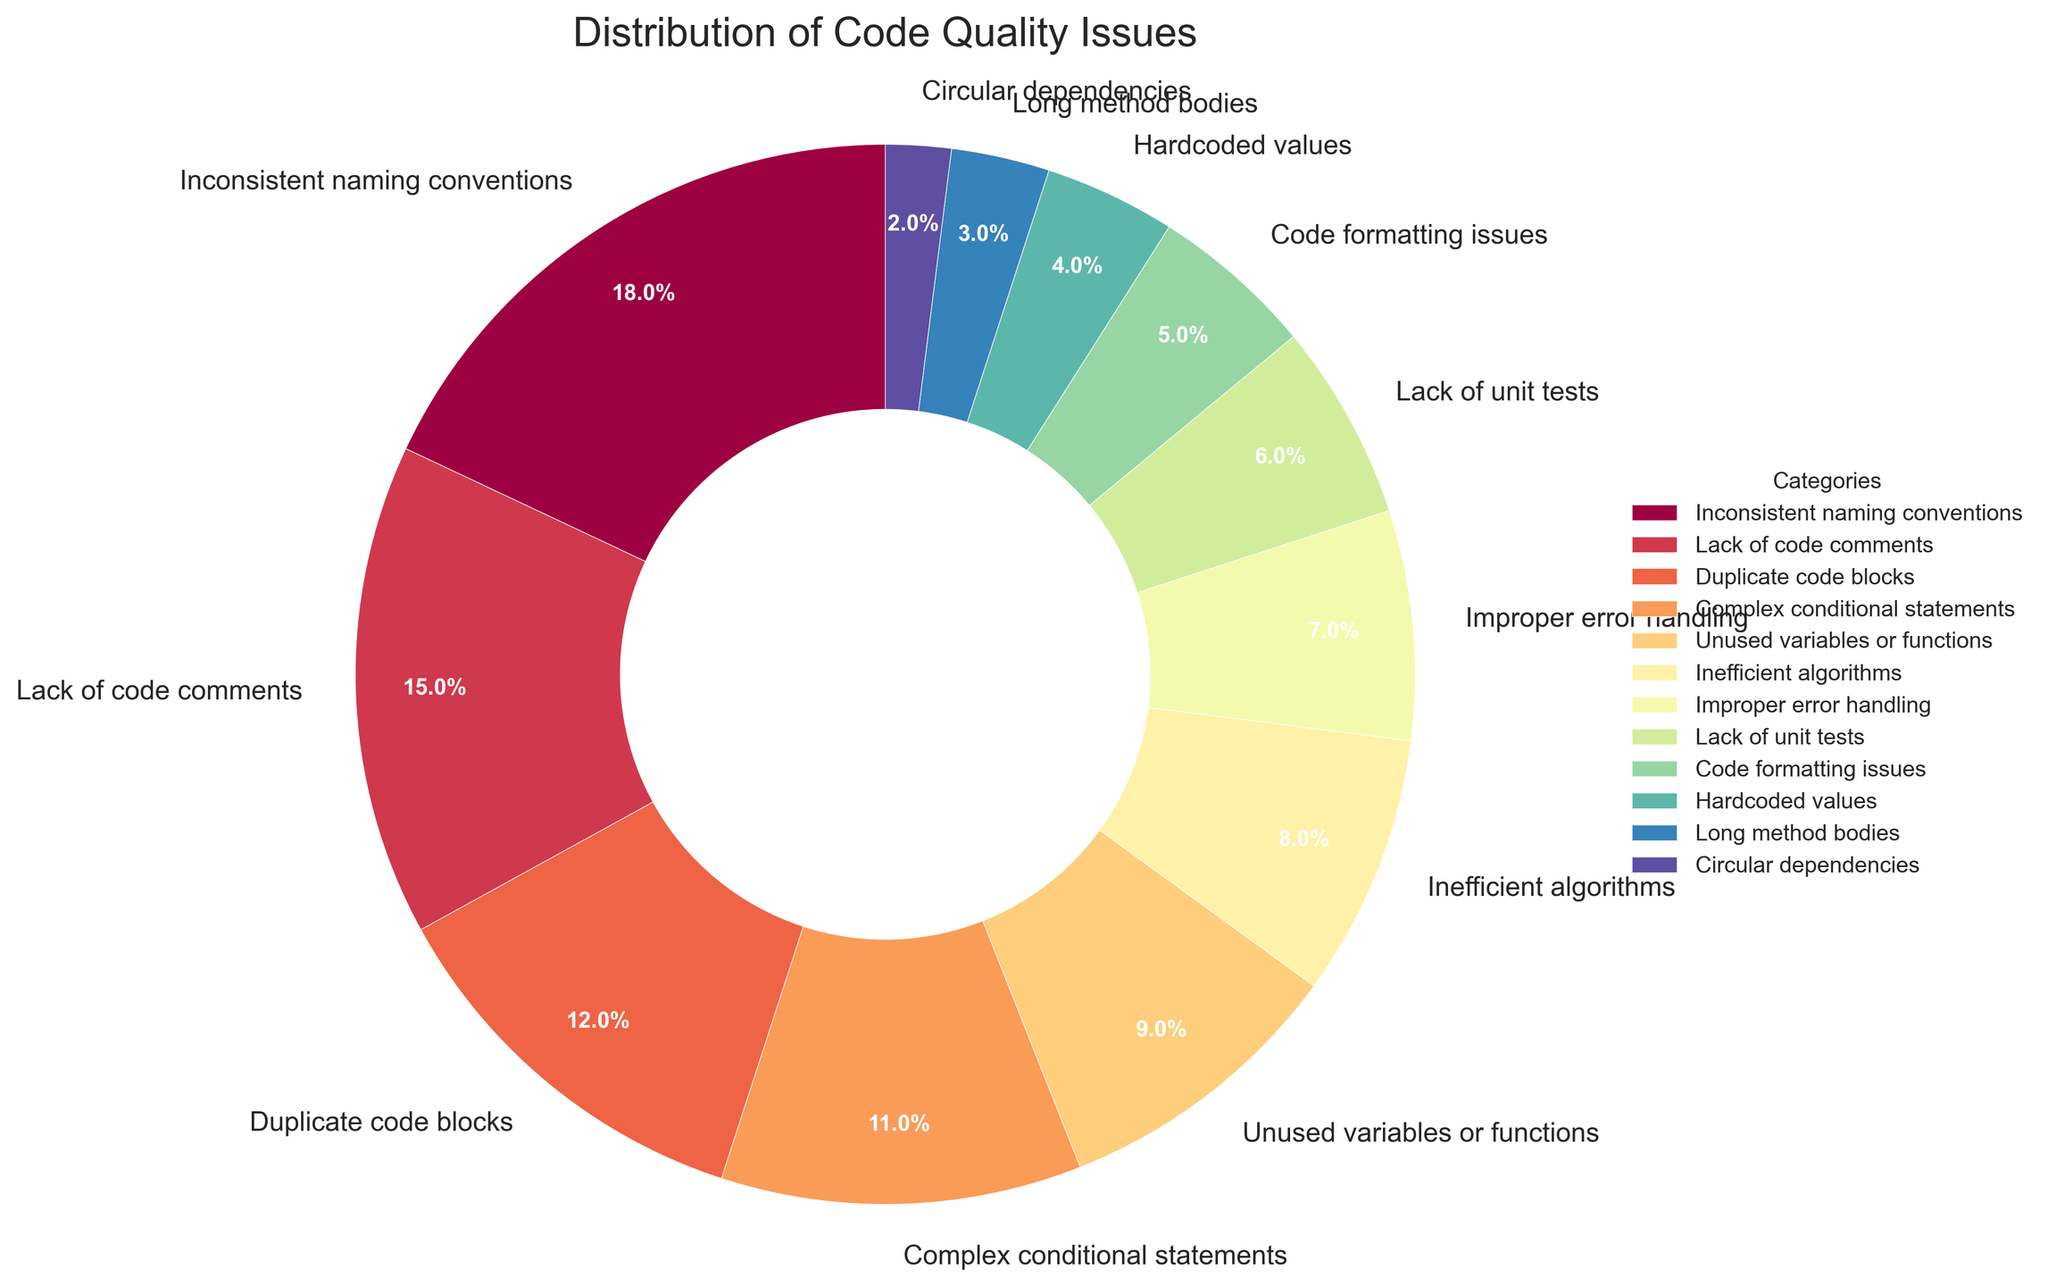Which category has the highest percentage of code quality issues? The category "Inconsistent naming conventions" has the highest percentage, which is indicated by the largest wedge in the pie chart.
Answer: Inconsistent naming conventions What is the combined percentage of "Duplicate code blocks" and "Complex conditional statements"? The percentage for "Duplicate code blocks" is 12%, and for "Complex conditional statements" is 11%. Adding these together gives 12% + 11% = 23%.
Answer: 23% How does the percentage of "Unused variables or functions" compare to "Improper error handling"? The percentage for "Unused variables or functions" is 9%, while "Improper error handling" is at 7%. Comparing them, 9% is greater than 7%.
Answer: 9% is greater than 7% Which issue category occupies the smallest portion of the pie chart? "Circular dependencies" occupies the smallest portion of the pie chart, indicated by the smallest wedge, which is 2%.
Answer: Circular dependencies What is the total percentage for issues related to "Lack of code comments" and "Code formatting issues"? The percentage for "Lack of code comments" is 15% and "Code formatting issues" is 5%. Therefore, 15% + 5% = 20%.
Answer: 20% If the total percentage of issues is considered 100%, what fraction of this is contributed by "Inefficient algorithms" and "Hardcoded values" combined? "Inefficient algorithms" contribute 8% and "Hardcoded values" contribute 4%. Combined, they contribute 8% + 4% = 12%. Therefore, 12% out of 100% is equivalent to 12/100 or 0.12.
Answer: 0.12 or 12% Is the percentage of "Lack of unit tests" greater than the sum of "Long method bodies" and "Circular dependencies"? The percentage for "Lack of unit tests" is 6%. The sum of percentages for "Long method bodies" (3%) and "Circular dependencies" (2%) is 3% + 2% = 5%. Since 6% > 5%, "Lack of unit tests" is greater.
Answer: Yes What is the difference in percentage between "Inconsistent naming conventions" and "Inefficient algorithms"? "Inconsistent naming conventions" has a percentage of 18%, while "Inefficient algorithms" has a percentage of 8%. The difference is 18% - 8% = 10%.
Answer: 10% Which categories have a percentage between 5% and 10%? The categories "Unused variables or functions" (9%), "Inefficient algorithms" (8%), "Improper error handling" (7%), and "Lack of unit tests" (6%) fall within this range.
Answer: Unused variables or functions, Inefficient algorithms, Improper error handling, Lack of unit tests 